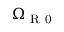Convert formula to latex. <formula><loc_0><loc_0><loc_500><loc_500>\Omega _ { R 0 }</formula> 